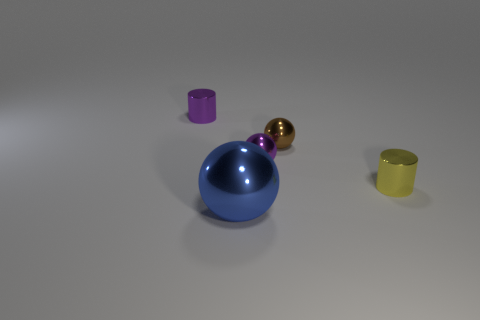Add 2 small purple metallic cylinders. How many objects exist? 7 Subtract all balls. How many objects are left? 2 Subtract all large blue spheres. Subtract all small brown metallic things. How many objects are left? 3 Add 3 things. How many things are left? 8 Add 2 big green matte objects. How many big green matte objects exist? 2 Subtract 0 cyan cylinders. How many objects are left? 5 